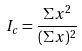<formula> <loc_0><loc_0><loc_500><loc_500>I _ { c } = \frac { \Sigma x ^ { 2 } } { ( \Sigma x ) ^ { 2 } }</formula> 